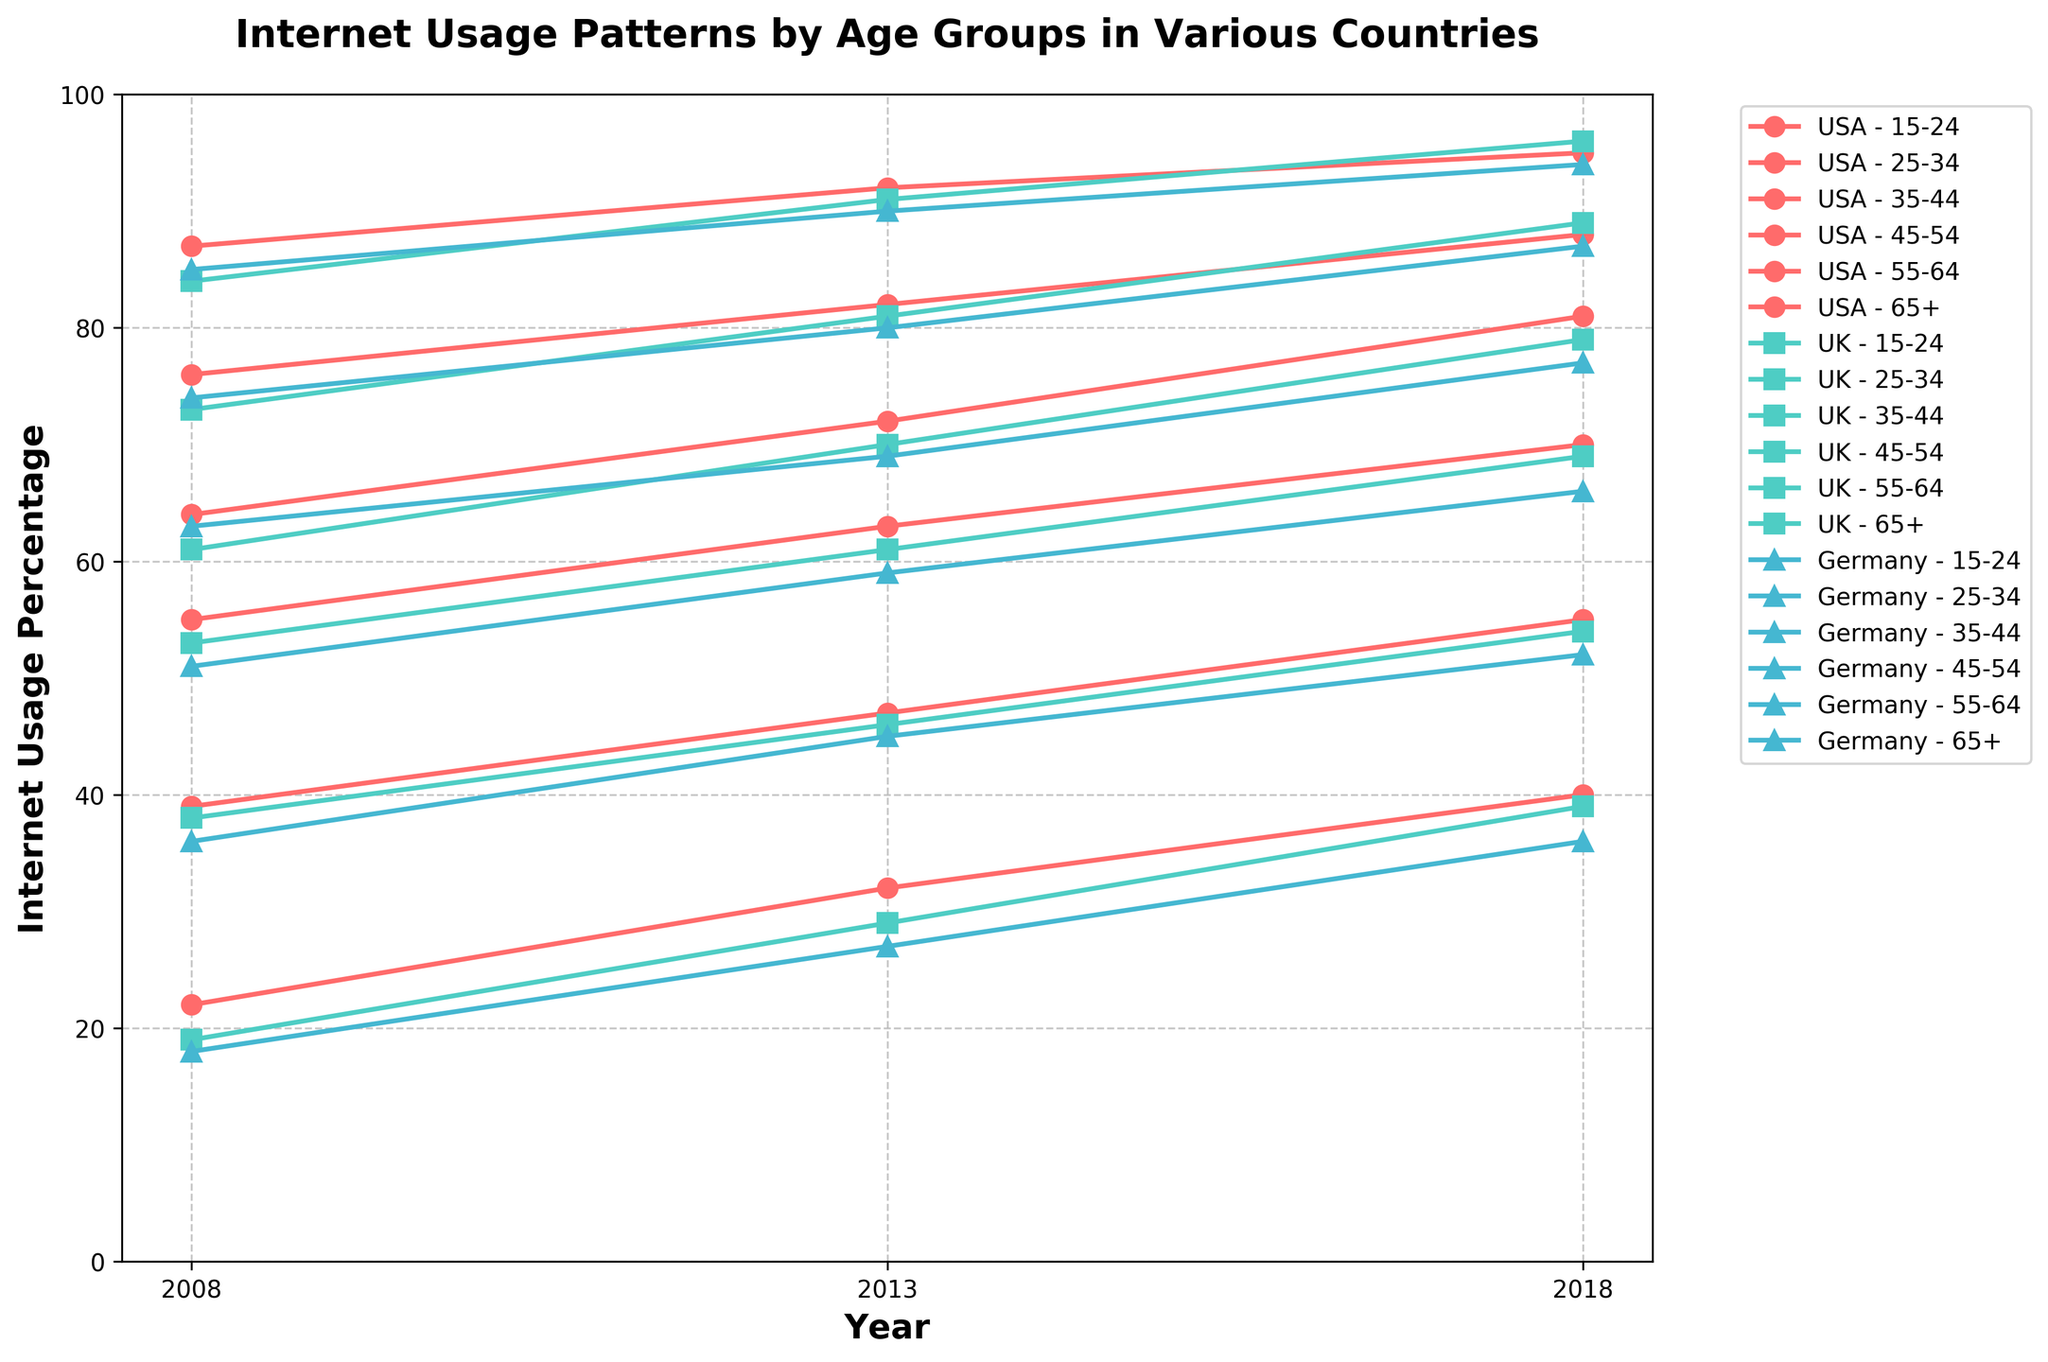What is the title of the figure? The title of the figure is written at the top, bold and in a larger font size. It reads "Internet Usage Patterns by Age Groups in Various Countries."
Answer: "Internet Usage Patterns by Age Groups in Various Countries" What is the internet usage percentage for the 15-24 age group in the USA in 2018? Locate the line representing the 15-24 age group for the USA and find the point where it intersects with the year 2018 on the x-axis. The corresponding y-axis value is the internet usage percentage.
Answer: 95% Between 2008 and 2018, which age group in Germany saw the greatest increase in internet usage percentage? Compare the increase in internet usage percentage for each age group from 2008 to 2018 by identifying the gap between the points on the y-axis in the respective years for Germany.
Answer: 65+ In which country did the 45-54 age group reach an internet usage of around 70% first, and in which year? Examine the lines for the 45-54 age group across all countries and see which one reaches around 70% on the y-axis first by following the timeline on the x-axis.
Answer: UK, 2018 What is the trend observed in the 65+ age group across all three countries from 2008 to 2018? Follow the lines representing the 65+ age group for all three countries over the years from 2008 to 2018 to identify the general direction or pattern.
Answer: Increasing trend In 2013, which age group in the USA had the highest internet usage percentage and what was it? Locate the data points for the USA in 2013 and find the age group with the highest value on the y-axis.
Answer: 15-24, 92% What's the difference in internet usage percentage between the 15-24 and 65+ age groups in the UK in 2018? Subtract the internet usage percentage of the 65+ age group from that of the 15-24 age group for the UK in the year 2018.
Answer: 57% Which country had the smallest increase in internet usage for the 55-64 age group from 2008 to 2018? Compare the increase in percentages for the 55-64 age group between 2008 and 2018 across all three countries.
Answer: Germany By how many percentage points did the internet usage in the UK for the 25-34 age group increase between 2008 and 2013? Subtract the internet usage percentage of the 25-34 age group in 2008 from that in 2013 for the UK.
Answer: 8 percentage points Which country had the highest internet usage percentage for the 35-44 age group in 2018? Identify the data points for the 35-44 age group in 2018 across all countries and select the one with the highest value on the y-axis.
Answer: USA 